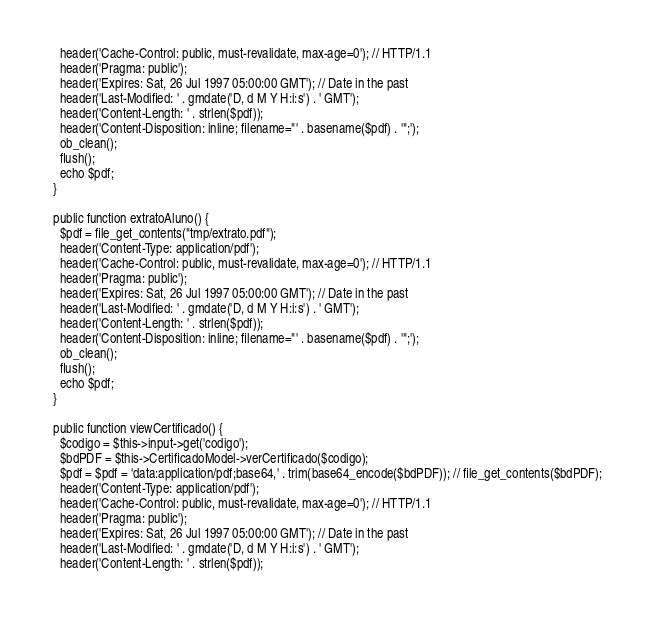<code> <loc_0><loc_0><loc_500><loc_500><_PHP_>    header('Cache-Control: public, must-revalidate, max-age=0'); // HTTP/1.1
    header('Pragma: public');
    header('Expires: Sat, 26 Jul 1997 05:00:00 GMT'); // Date in the past
    header('Last-Modified: ' . gmdate('D, d M Y H:i:s') . ' GMT');
    header('Content-Length: ' . strlen($pdf));
    header('Content-Disposition: inline; filename="' . basename($pdf) . '";');
    ob_clean();
    flush();
    echo $pdf;
  }
  
  public function extratoAluno() {
    $pdf = file_get_contents("tmp/extrato.pdf");
    header('Content-Type: application/pdf');
    header('Cache-Control: public, must-revalidate, max-age=0'); // HTTP/1.1
    header('Pragma: public');
    header('Expires: Sat, 26 Jul 1997 05:00:00 GMT'); // Date in the past
    header('Last-Modified: ' . gmdate('D, d M Y H:i:s') . ' GMT');
    header('Content-Length: ' . strlen($pdf));
    header('Content-Disposition: inline; filename="' . basename($pdf) . '";');
    ob_clean();
    flush();
    echo $pdf;
  }

  public function viewCertificado() {
    $codigo = $this->input->get('codigo');
    $bdPDF = $this->CertificadoModel->verCertificado($codigo);
    $pdf = $pdf = 'data:application/pdf;base64,' . trim(base64_encode($bdPDF)); // file_get_contents($bdPDF);
    header('Content-Type: application/pdf');
    header('Cache-Control: public, must-revalidate, max-age=0'); // HTTP/1.1
    header('Pragma: public');
    header('Expires: Sat, 26 Jul 1997 05:00:00 GMT'); // Date in the past
    header('Last-Modified: ' . gmdate('D, d M Y H:i:s') . ' GMT');
    header('Content-Length: ' . strlen($pdf));</code> 